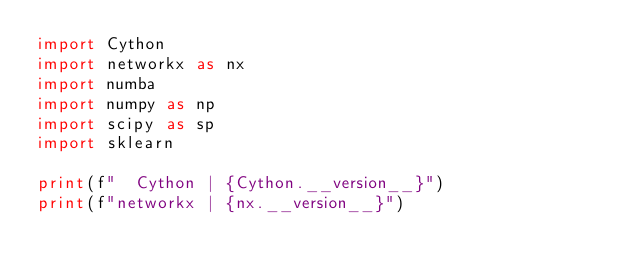<code> <loc_0><loc_0><loc_500><loc_500><_Python_>import Cython
import networkx as nx
import numba
import numpy as np
import scipy as sp
import sklearn

print(f"  Cython | {Cython.__version__}")
print(f"networkx | {nx.__version__}")</code> 